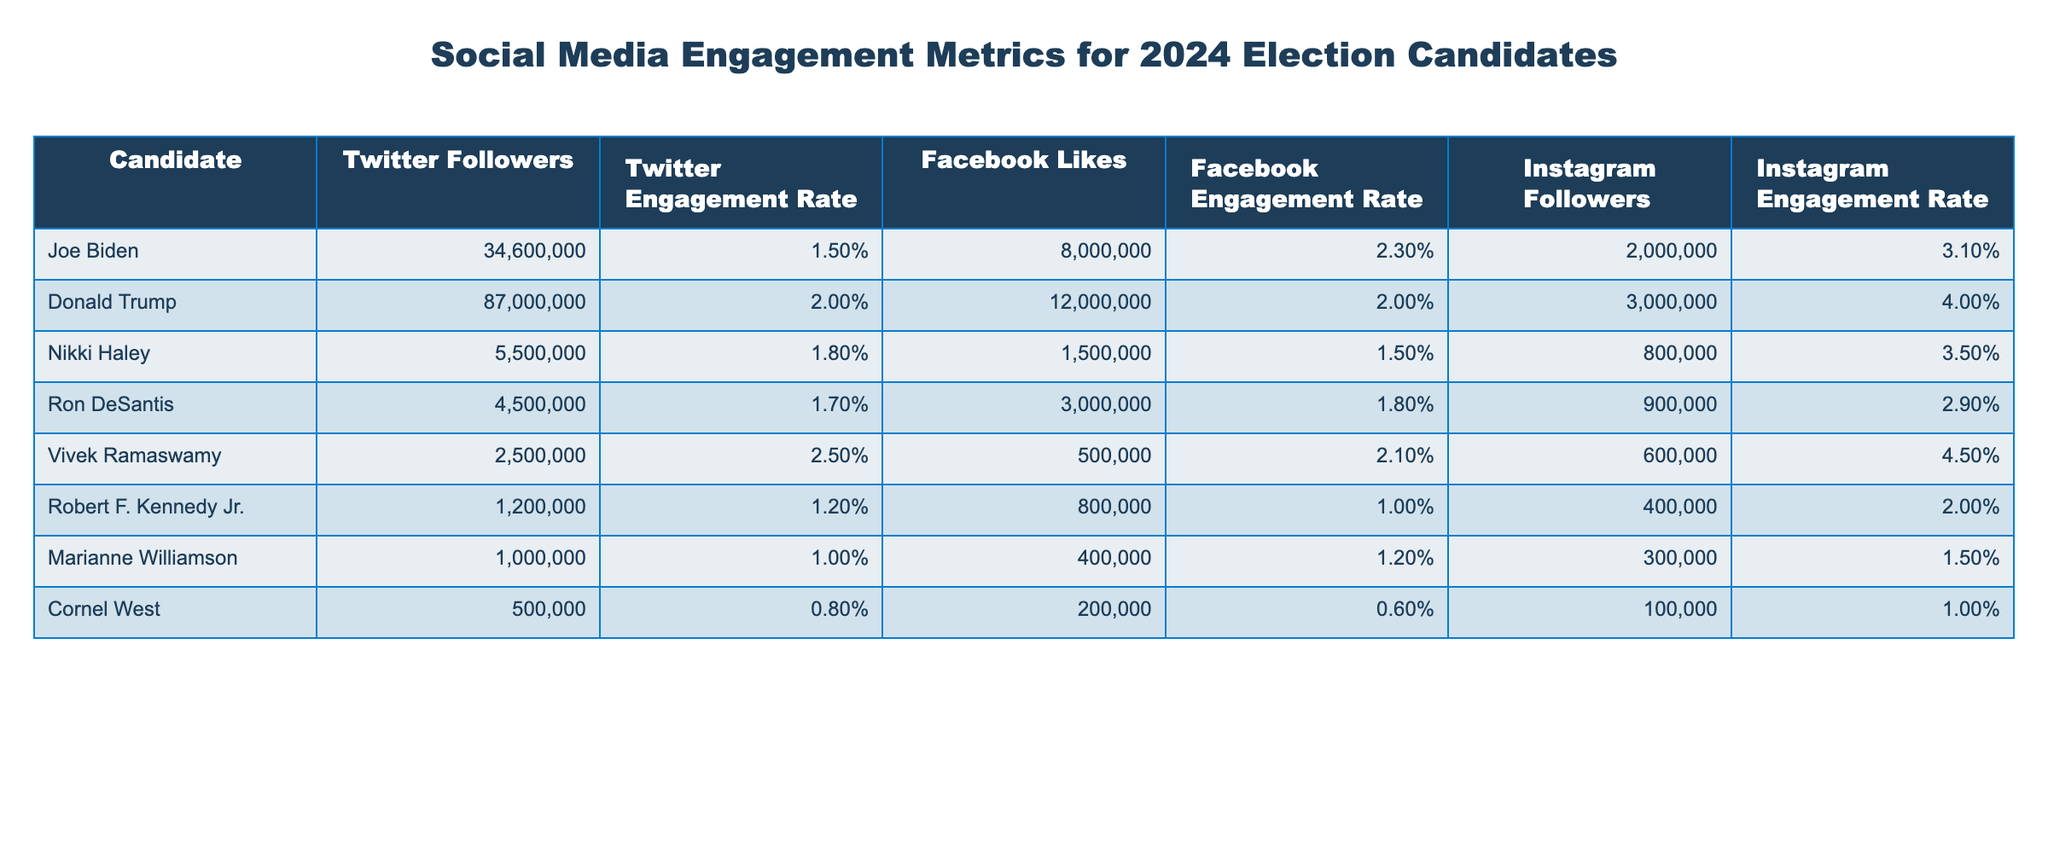What is the Twitter follower count of Donald Trump? The table shows that Donald Trump has 87,000,000 Twitter followers.
Answer: 87,000,000 Who has the highest Instagram engagement rate among the candidates? By comparing the Instagram engagement rates, Vivek Ramaswamy has the highest rate at 4.5%.
Answer: 4.5% What is the total number of Facebook likes of Joe Biden and Nikki Haley combined? Joe Biden has 8,000,000 likes and Nikki Haley has 1,500,000 likes. Adding these gives 8,000,000 + 1,500,000 = 9,500,000.
Answer: 9,500,000 Is Vivek Ramaswamy's Twitter engagement rate higher than Joe Biden's? Vivek Ramaswamy's engagement rate is 2.5%, while Joe Biden's is 1.5%. Thus, Vivek Ramaswamy's rate is higher.
Answer: Yes What is the difference in Instagram follower counts between Donald Trump and Marianne Williamson? Donald Trump has 3,000,000 Instagram followers and Marianne Williamson has 300,000. The difference is 3,000,000 - 300,000 = 2,700,000.
Answer: 2,700,000 Which candidate has the lowest Facebook engagement rate? Looking at the Facebook engagement rates in the table, Cornel West has the lowest engagement rate at 0.6%.
Answer: 0.6% What is the average Twitter engagement rate for all candidates listed? The Twitter engagement rates are 1.5%, 2.0%, 1.8%, 1.7%, 2.5%, 1.2%, 1.0%, and 0.8%. The sum is 12.5% and there are 8 candidates, resulting in an average of 12.5% / 8 = 1.5625%.
Answer: 1.56% Do any candidates have an Instagram engagement rate greater than 4%? Yes, both Donald Trump (4.0%) and Vivek Ramaswamy (4.5%) have Instagram engagement rates greater than 4%.
Answer: Yes Which candidate has the highest total social media follower count across all platforms? Summing the followers for each platform reveals that Donald Trump has 87,000,000 + 12,000,000 + 3,000,000 = 102,000,000, which is the highest total across all candidates.
Answer: 102,000,000 What percentage of Joe Biden's Instagram followers engage according to the engagement rate? Joe Biden has 2,000,000 Instagram followers and an engagement rate of 3.1%. Calculating this gives 2,000,000 * 0.031 = 62,000.
Answer: 62,000 